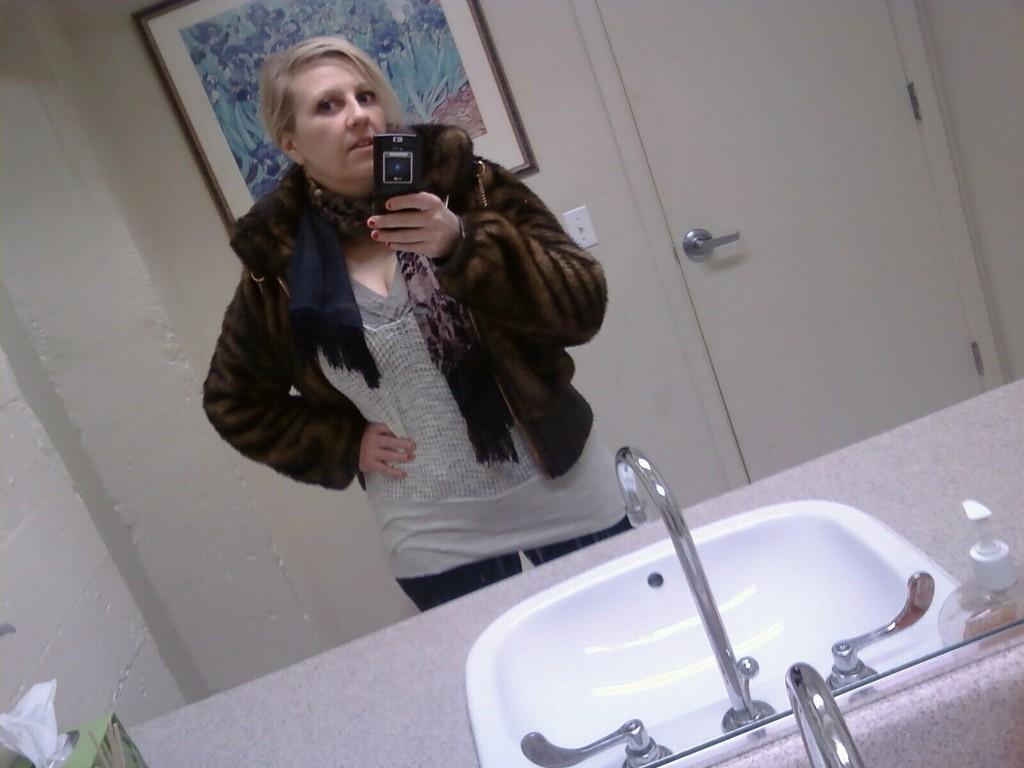How would you summarize this image in a sentence or two? In the image there is a lady with brown jacket and she is holding the mobile in her hand. In front of her there is a sink with tap. Behind her there is a wall with frame, switchboard and also there is a door. 